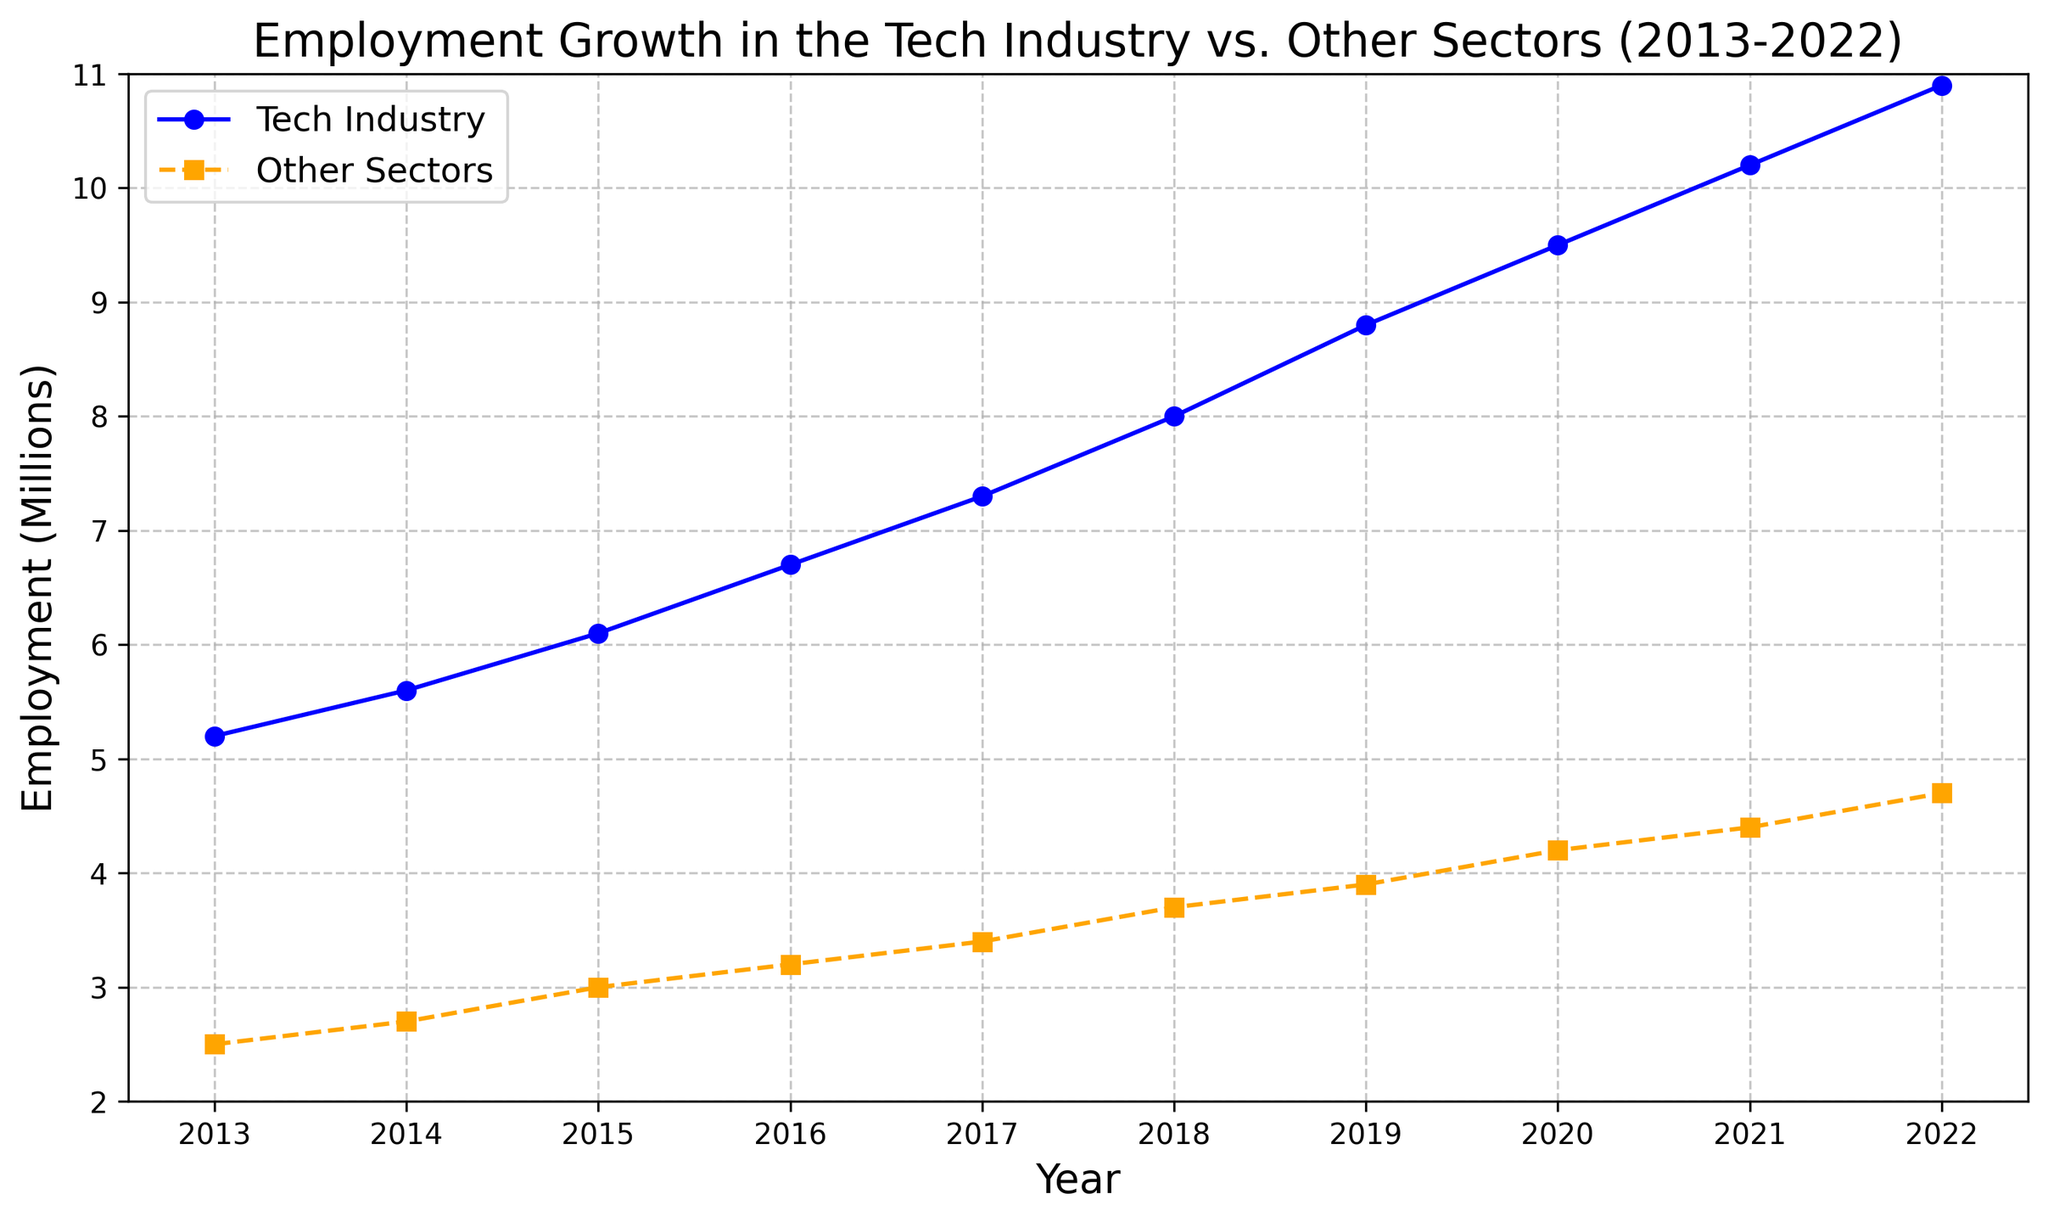What's the average annual growth in employment in the tech industry from 2013 to 2022? First, find the employment in the tech industry for 2022 and 2013, which are 10.9 million and 5.2 million respectively. The difference between these years is 10.9 - 5.2 = 5.7 million. The average annual growth over 9 years is then 5.7 / 9 ≈ 0.63 million per year.
Answer: 0.63 million per year In which year did the tech industry employment first exceed 8 million? Locate the tech industry line and track years until the employment value exceeds 8 million. This occurs in 2018.
Answer: 2018 How much higher was tech industry employment compared to other sectors in 2020? Find the employment values for both sectors in 2020: Tech Industry at 9.5 million and Other Sectors at 4.2 million. The difference is 9.5 - 4.2 = 5.3 million.
Answer: 5.3 million Which sector had a higher employment growth rate in 2016 compared to 2013? For the Tech Industry: (6.7 - 5.2) / 5.2 * 100 ≈ 28.85%. For Other Sectors: (3.2 - 2.5) / 2.5 * 100 = 28%. Tech Industry has the higher growth rate.
Answer: Tech Industry What is the overall trend in tech industry employment over the decade? By observing the blue line with markers denoting the tech industry, it is clear that the employment consistently increases each year. This demonstrates a positive and steady growth trend.
Answer: Increasing trend How does the employment growth pattern in other sectors from 2019 to 2022 compare to that in the tech industry? For the other sectors, the employment increases from 3.9 to 4.7 million, a difference of 0.8 million. For the tech industry, it increases from 8.8 to 10.9 million, a difference of 2.1 million. Thus, the tech industry saw a larger increase.
Answer: Tech Industry saw larger growth What can you infer about job security in the tech industry based on this chart? By examining the steady and significant increase in tech industry employment over the decade, one could infer that the tech industry has experienced consistent growth, suggesting higher potential for job security.
Answer: High job security What was the percentage increase in other sectors' employment from 2013 to 2022? Other Sectors in 2013: 2.5 million, in 2022: 4.7 million. Percentage increase is ((4.7 - 2.5) / 2.5) * 100 = 88%.
Answer: 88% Which year shows the highest employment gap between the tech industry and other sectors? By visually comparing the gap between the blue and orange lines for each year, 2022 shows the largest gap, approximately 10.9 - 4.7 = 6.2 million.
Answer: 2022 